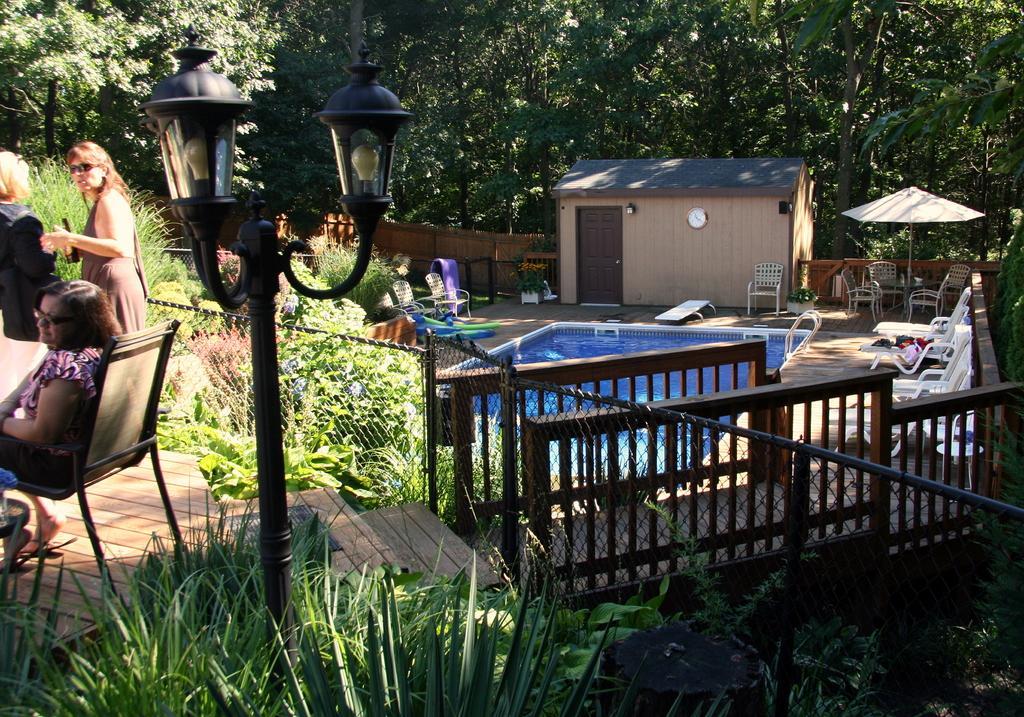Please provide a concise description of this image. In this image we can see a house and in front of the house we can see a swimming pool, fencing and a group of plants. Behind the house we can see a wooden fence and a group of trees. On the right side we have group of chairs and a table. On the left side there are three persons, a chair, table and a pole with lights. 